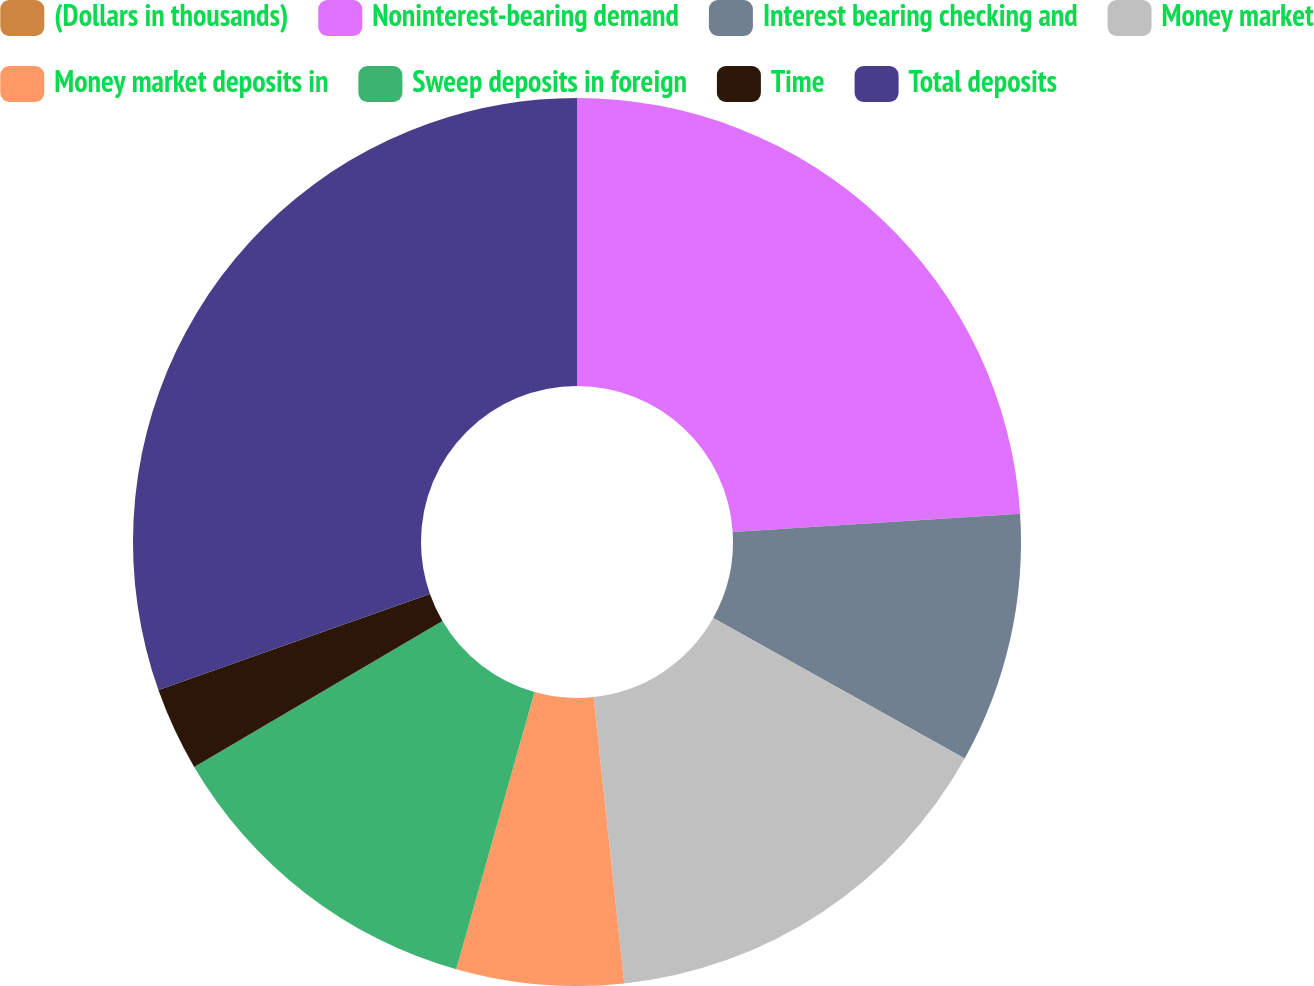Convert chart. <chart><loc_0><loc_0><loc_500><loc_500><pie_chart><fcel>(Dollars in thousands)<fcel>Noninterest-bearing demand<fcel>Interest bearing checking and<fcel>Money market<fcel>Money market deposits in<fcel>Sweep deposits in foreign<fcel>Time<fcel>Total deposits<nl><fcel>0.0%<fcel>23.98%<fcel>9.12%<fcel>15.2%<fcel>6.08%<fcel>12.16%<fcel>3.04%<fcel>30.41%<nl></chart> 